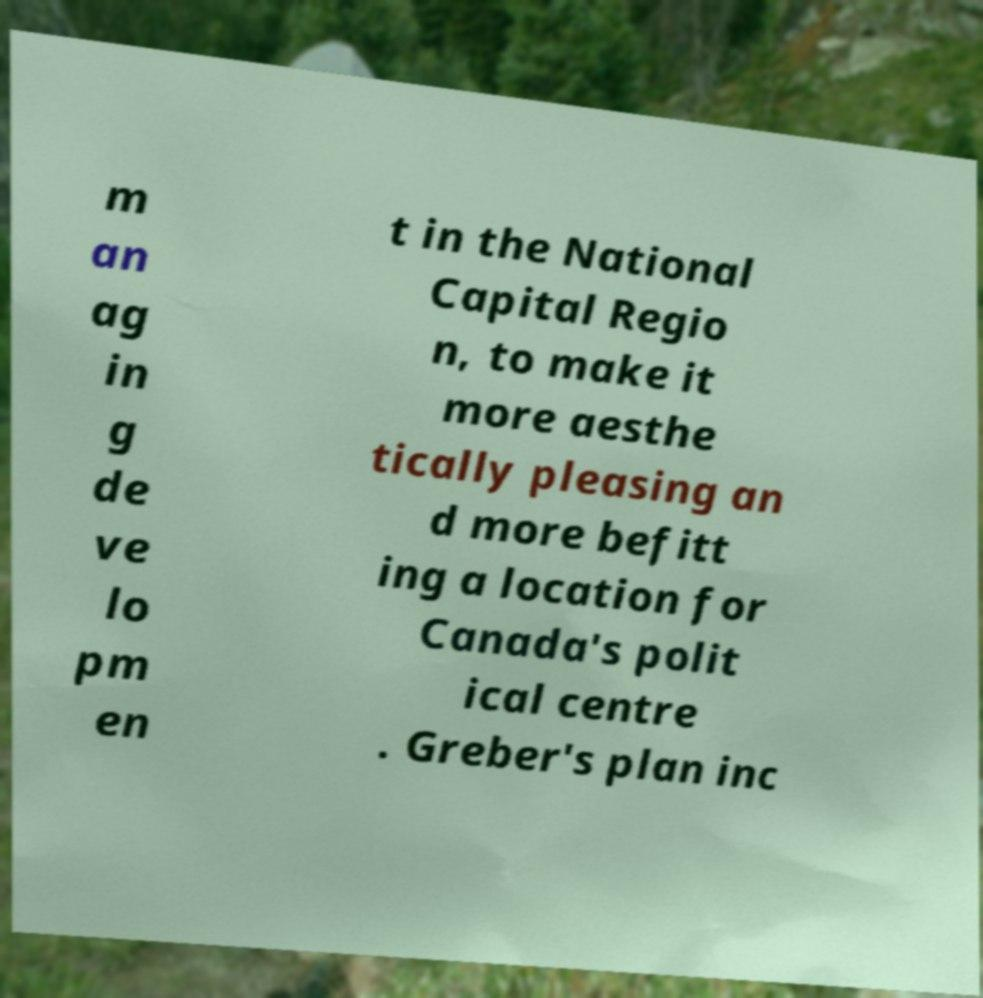Please identify and transcribe the text found in this image. m an ag in g de ve lo pm en t in the National Capital Regio n, to make it more aesthe tically pleasing an d more befitt ing a location for Canada's polit ical centre . Greber's plan inc 